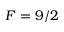<formula> <loc_0><loc_0><loc_500><loc_500>F = 9 / 2</formula> 